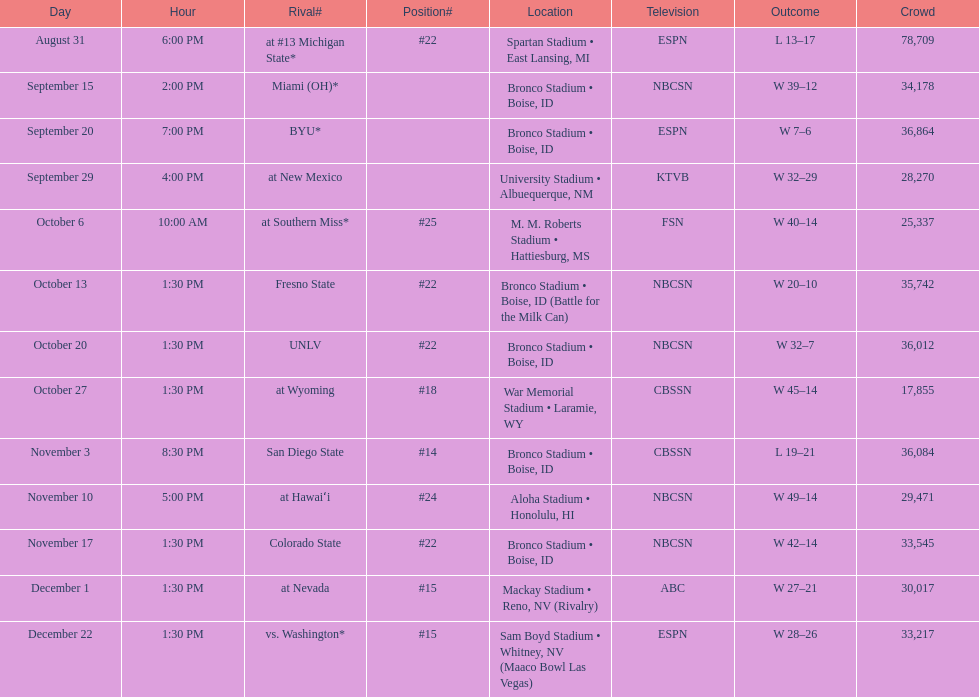Could you help me parse every detail presented in this table? {'header': ['Day', 'Hour', 'Rival#', 'Position#', 'Location', 'Television', 'Outcome', 'Crowd'], 'rows': [['August 31', '6:00 PM', 'at\xa0#13\xa0Michigan State*', '#22', 'Spartan Stadium • East Lansing, MI', 'ESPN', 'L\xa013–17', '78,709'], ['September 15', '2:00 PM', 'Miami (OH)*', '', 'Bronco Stadium • Boise, ID', 'NBCSN', 'W\xa039–12', '34,178'], ['September 20', '7:00 PM', 'BYU*', '', 'Bronco Stadium • Boise, ID', 'ESPN', 'W\xa07–6', '36,864'], ['September 29', '4:00 PM', 'at\xa0New Mexico', '', 'University Stadium • Albuequerque, NM', 'KTVB', 'W\xa032–29', '28,270'], ['October 6', '10:00 AM', 'at\xa0Southern Miss*', '#25', 'M. M. Roberts Stadium • Hattiesburg, MS', 'FSN', 'W\xa040–14', '25,337'], ['October 13', '1:30 PM', 'Fresno State', '#22', 'Bronco Stadium • Boise, ID (Battle for the Milk Can)', 'NBCSN', 'W\xa020–10', '35,742'], ['October 20', '1:30 PM', 'UNLV', '#22', 'Bronco Stadium • Boise, ID', 'NBCSN', 'W\xa032–7', '36,012'], ['October 27', '1:30 PM', 'at\xa0Wyoming', '#18', 'War Memorial Stadium • Laramie, WY', 'CBSSN', 'W\xa045–14', '17,855'], ['November 3', '8:30 PM', 'San Diego State', '#14', 'Bronco Stadium • Boise, ID', 'CBSSN', 'L\xa019–21', '36,084'], ['November 10', '5:00 PM', 'at\xa0Hawaiʻi', '#24', 'Aloha Stadium • Honolulu, HI', 'NBCSN', 'W\xa049–14', '29,471'], ['November 17', '1:30 PM', 'Colorado State', '#22', 'Bronco Stadium • Boise, ID', 'NBCSN', 'W\xa042–14', '33,545'], ['December 1', '1:30 PM', 'at\xa0Nevada', '#15', 'Mackay Stadium • Reno, NV (Rivalry)', 'ABC', 'W\xa027–21', '30,017'], ['December 22', '1:30 PM', 'vs.\xa0Washington*', '#15', 'Sam Boyd Stadium • Whitney, NV (Maaco Bowl Las Vegas)', 'ESPN', 'W\xa028–26', '33,217']]} Number of points scored by miami (oh) against the broncos. 12. 